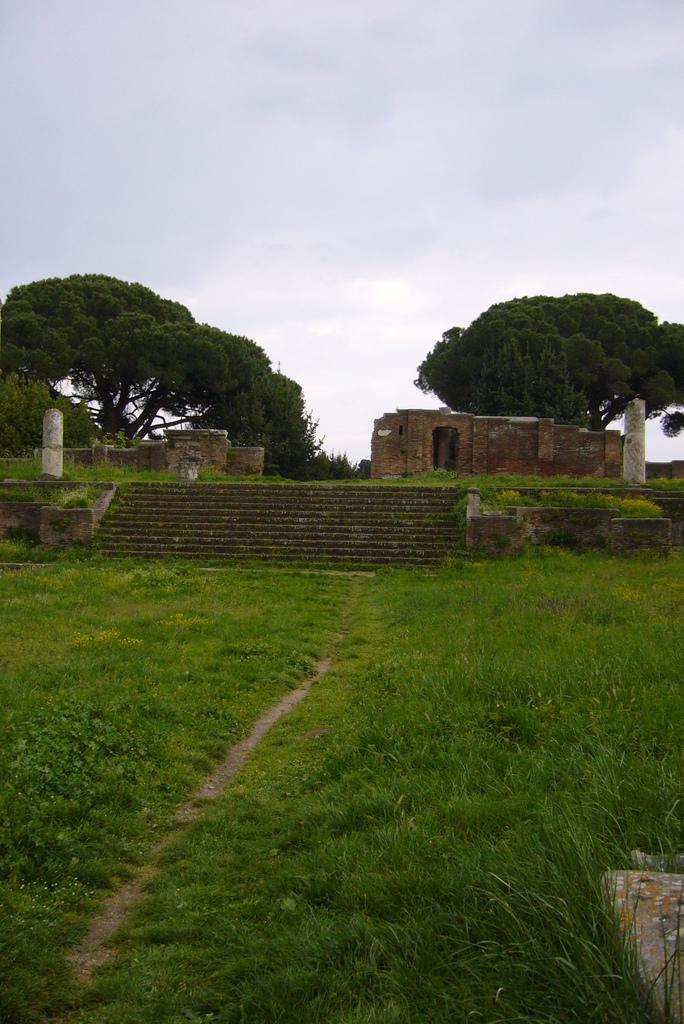What type of vegetation is present on the ground in the image? There is grass on the ground in the image. What structures can be seen in the background of the image? Poles, walls, and trees are visible in the background of the image. What part of the natural environment is visible in the image? The sky is visible at the top of the image. What type of table is being used by the spy in the image? There is no spy or table present in the image. 